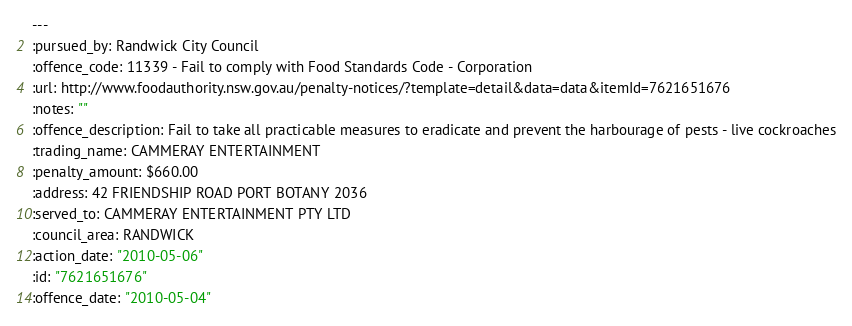Convert code to text. <code><loc_0><loc_0><loc_500><loc_500><_YAML_>--- 
:pursued_by: Randwick City Council
:offence_code: 11339 - Fail to comply with Food Standards Code - Corporation
:url: http://www.foodauthority.nsw.gov.au/penalty-notices/?template=detail&data=data&itemId=7621651676
:notes: ""
:offence_description: Fail to take all practicable measures to eradicate and prevent the harbourage of pests - live cockroaches
:trading_name: CAMMERAY ENTERTAINMENT
:penalty_amount: $660.00
:address: 42 FRIENDSHIP ROAD PORT BOTANY 2036
:served_to: CAMMERAY ENTERTAINMENT PTY LTD
:council_area: RANDWICK
:action_date: "2010-05-06"
:id: "7621651676"
:offence_date: "2010-05-04"
</code> 